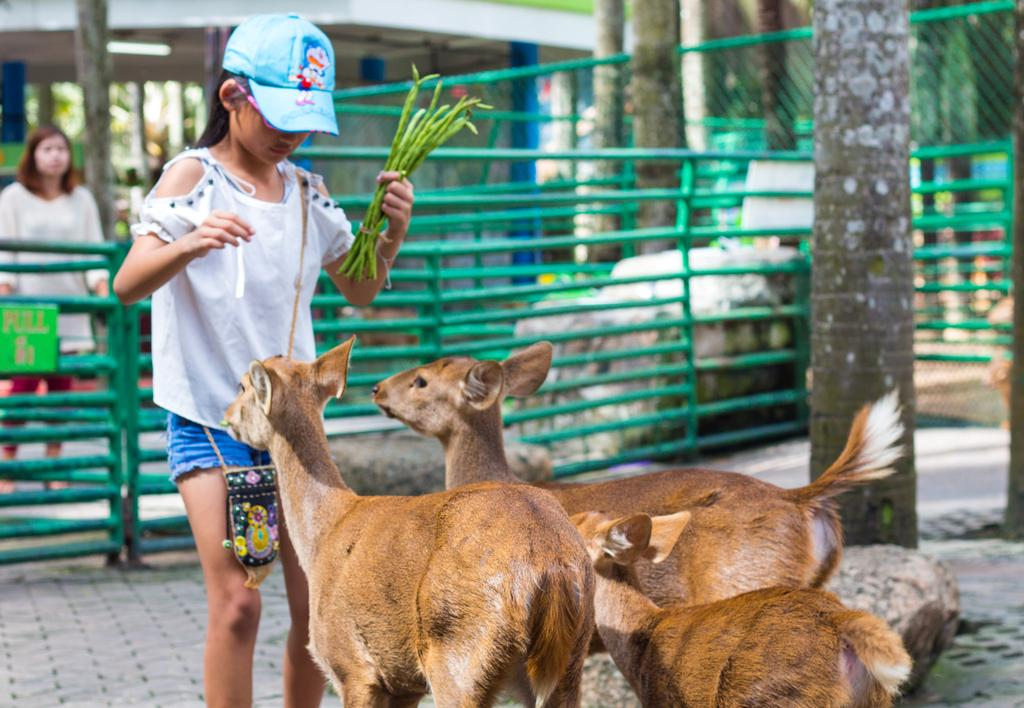What animals can be seen in the image? There are deer in the image. What is the girl in the image doing? The girl is standing and holding leaves. What type of barrier is visible in the image? There is fencing visible in the image. Can you describe the woman's position in the image? There is a woman standing at the back. What type of vegetation is present in the image? Trees are present in the image. What type of structure is visible in the image? There are walls visible in the image. What brand of toothpaste is the deer using in the image? There is no toothpaste present in the image, and the deer is not using any toothpaste. 